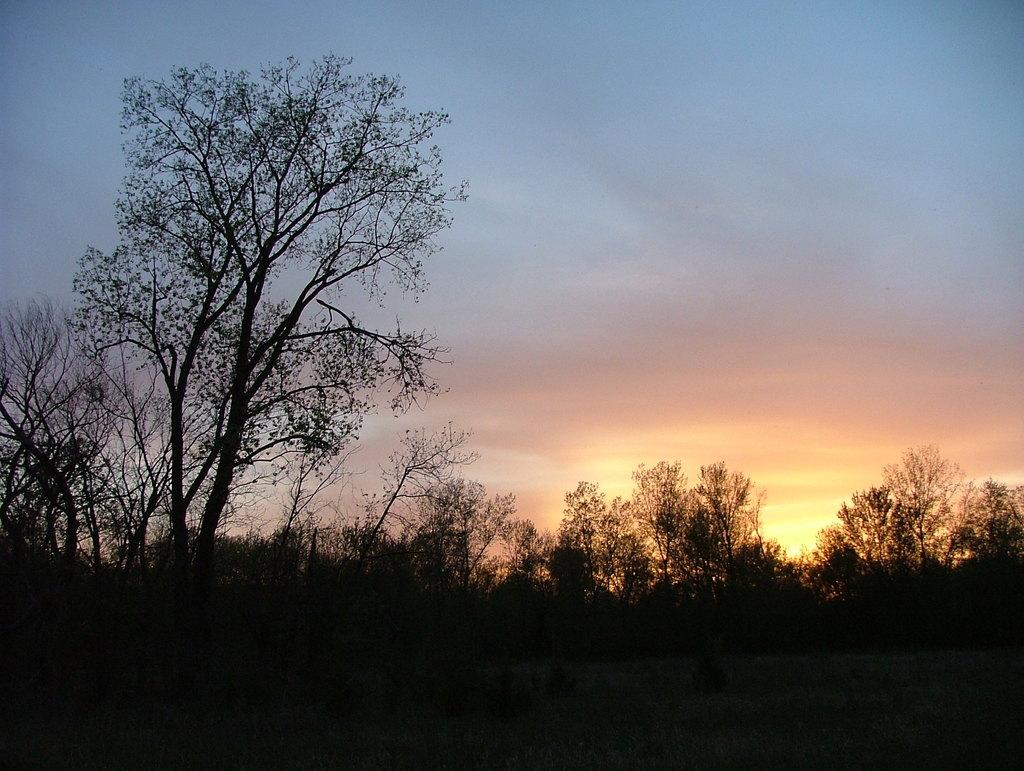What type of natural environment is depicted in the image? The image contains a view of the forest. Can you describe the trees in the front of the image? There are many dry trees in the front of the image. What can be seen in the background of the image? There is a sunset sky visible in the background of the image. Where is the nearest airport to the location depicted in the image? The provided facts do not mention any airport or location, so it is not possible to determine the nearest airport to the scene in the image. 